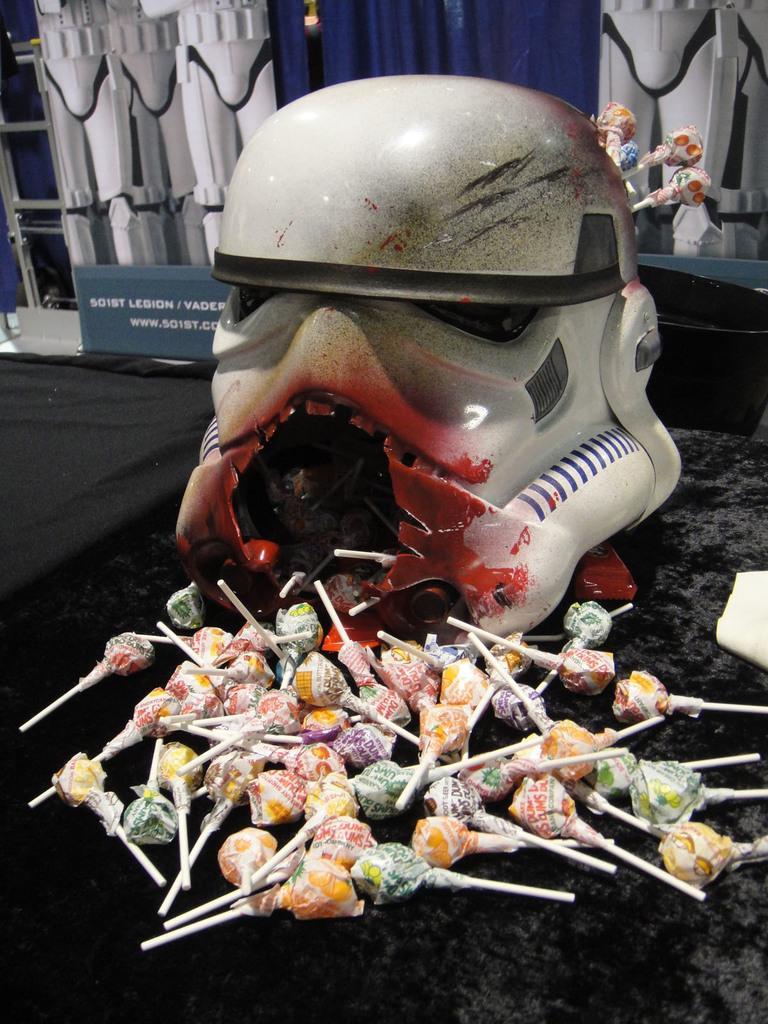In one or two sentences, can you explain what this image depicts? In the picture I can see lollipops, a sculpture, a board and a few more objects in the background. 